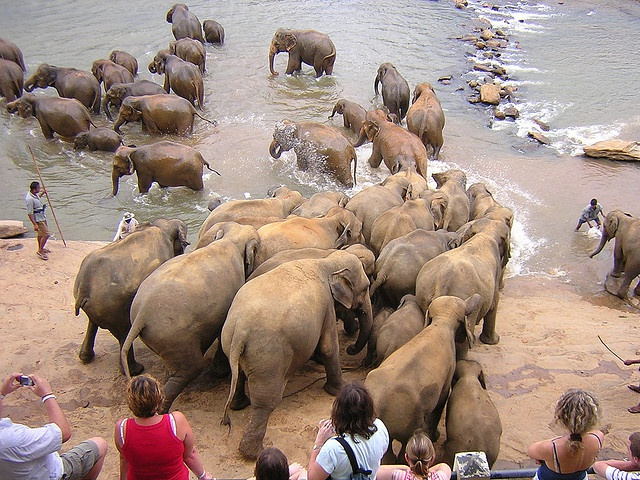Describe the objects in this image and their specific colors. I can see elephant in darkgray, tan, gray, and black tones, elephant in darkgray, gray, tan, and maroon tones, people in darkgray, brown, maroon, and black tones, people in darkgray, gray, and lavender tones, and people in darkgray, black, lavender, and gray tones in this image. 